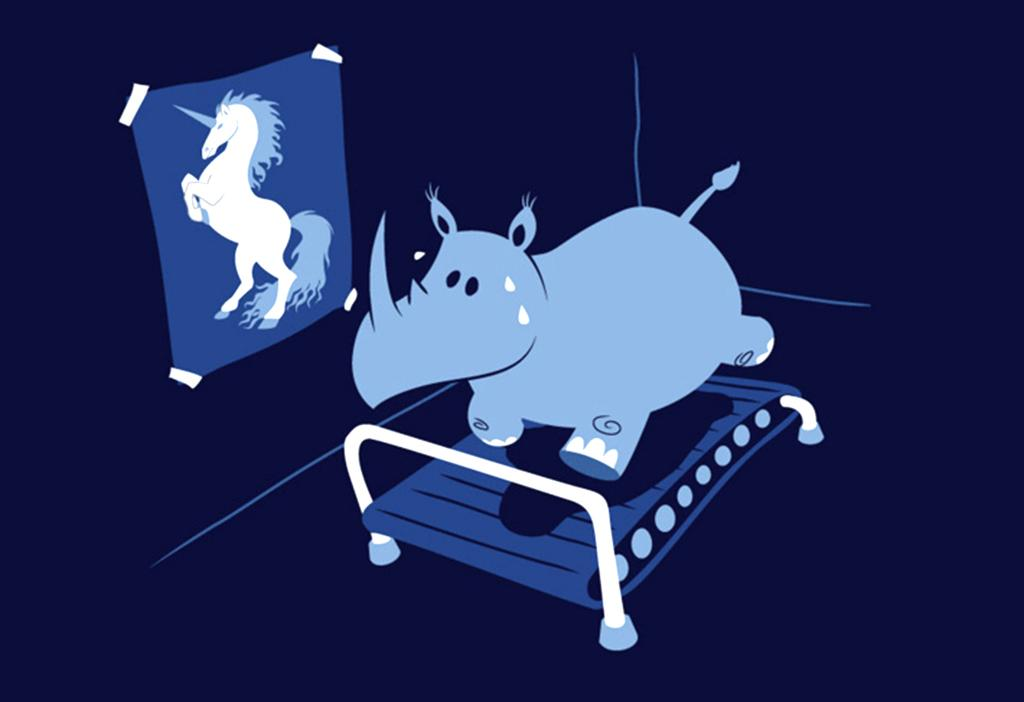What type of image is being described? The image appears to be animated. What piece of furniture is present in the image? There is a bed in the image. What kind of living creature can be seen in the image? There is an animal in the image. What is depicted on the poster in the image? There is a poster of a horse in the image. How would you describe the background of the image? The background of the image is colored. How many buns are on the bed in the image? There are no buns present in the image; it features a bed, an animal, and a poster of a horse. What type of card is being held by the animal in the image? There is no card present in the image; it only features a bed, an animal, and a poster of a horse. 